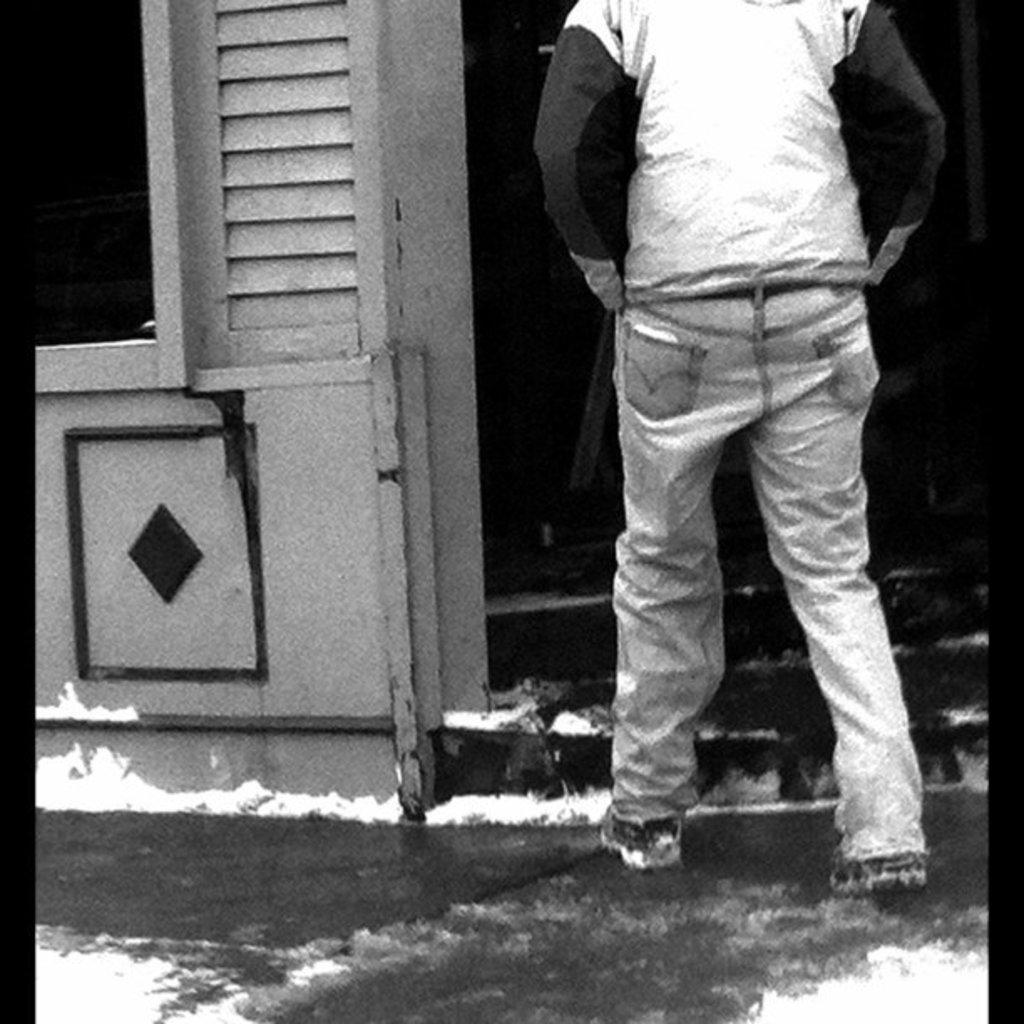How would you summarize this image in a sentence or two? In this image I can see a person is standing in the front. In the background I can see stairs and I can see this image is black and white in colour. 